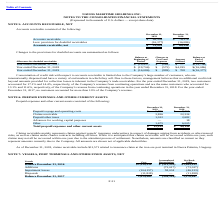According to Navios Maritime Holdings's financial document, What does claims receivable represent?  claims against vessels’ insurance underwriters in respect of damages arising from accidents or other insured risks, as well as claims under charter contracts including off-hires.. The document states: "Claims receivable mainly represents claims against vessels’ insurance underwriters in respect of damages arising from accidents or other insured risks..." Also, Which years does the table provide information for Prepaid expenses and other current assets? The document shows two values: 2019 and 2018. From the document: "2019 2018..." Also, What were the prepaid other taxes in 2019? According to the financial document, 1,012 (in thousands). The relevant text states: "Prepaid other taxes 1,012 2,682..." Also, How many years did Total prepaid expenses and other current assets exceed $20,000 thousand? Based on the analysis, there are 1 instances. The counting process: 2018. Also, can you calculate: What was the change in claims receivable between 2018 and 2019? Based on the calculation: 3,826-22,224, the result is -18398 (in thousands). This is based on the information: "Claims receivable 3,826 22,224 Claims receivable 3,826 22,224..." The key data points involved are: 22,224, 3,826. Also, can you calculate: What was the percentage change in other current assets between 2018 and 2019? To answer this question, I need to perform calculations using the financial data. The calculation is: (1,675-6,005)/6,005, which equals -72.11 (percentage). This is based on the information: "Other 1,675 6,005 Other 1,675 6,005..." The key data points involved are: 1,675, 6,005. 